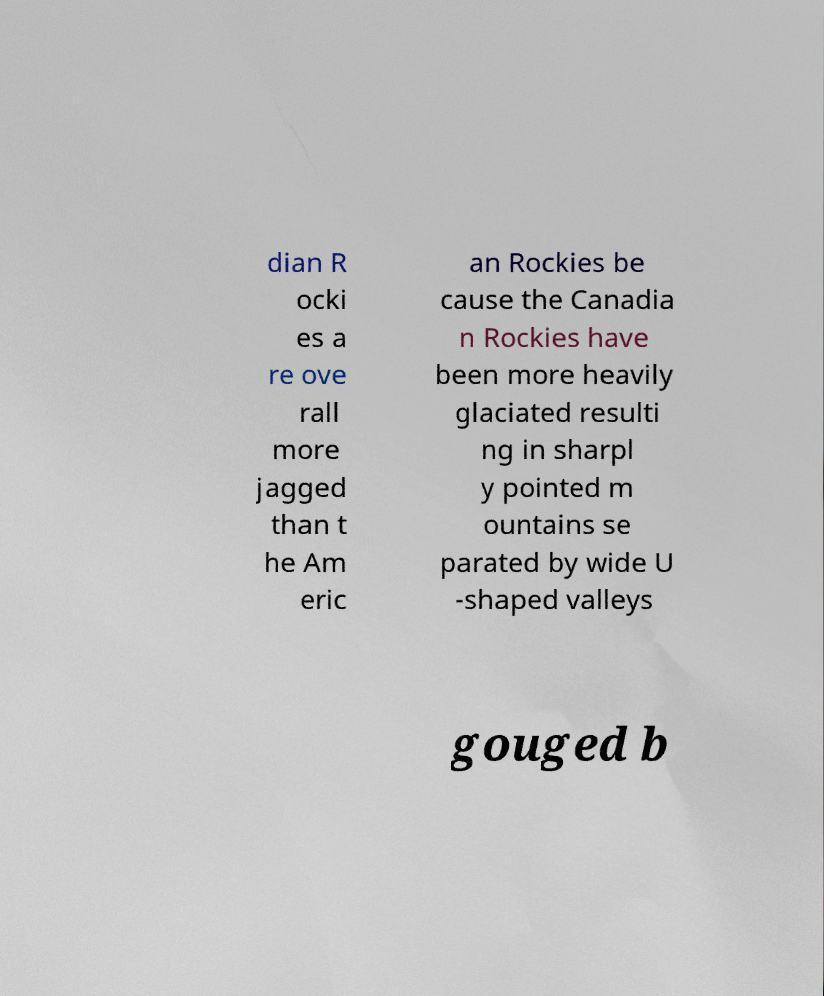There's text embedded in this image that I need extracted. Can you transcribe it verbatim? dian R ocki es a re ove rall more jagged than t he Am eric an Rockies be cause the Canadia n Rockies have been more heavily glaciated resulti ng in sharpl y pointed m ountains se parated by wide U -shaped valleys gouged b 